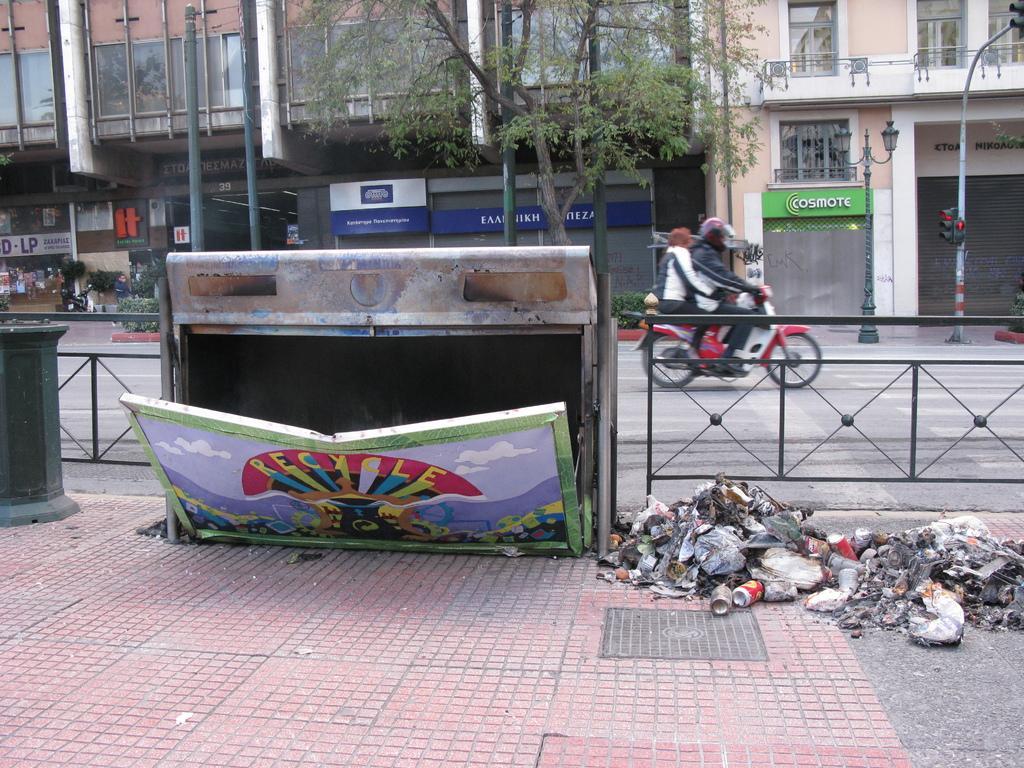Please provide a concise description of this image. In this image, we can see two persons sitting on the bike and on the bottom right, there is a waste on the side way. I n the background, there are trees, buildings, name boards, poles, lights and some plants are there. 